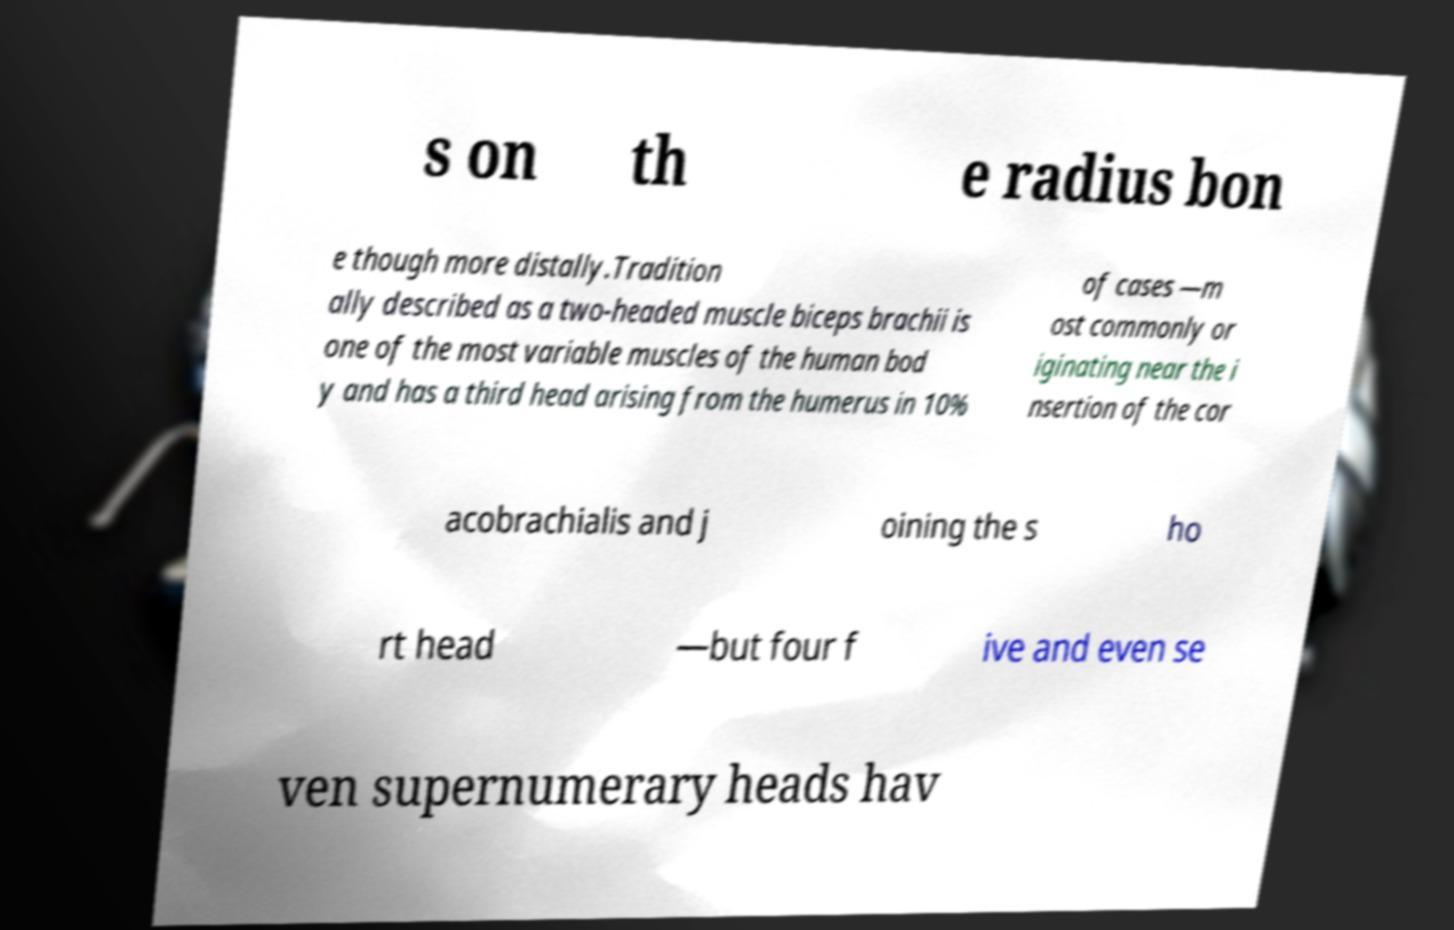Can you accurately transcribe the text from the provided image for me? s on th e radius bon e though more distally.Tradition ally described as a two-headed muscle biceps brachii is one of the most variable muscles of the human bod y and has a third head arising from the humerus in 10% of cases —m ost commonly or iginating near the i nsertion of the cor acobrachialis and j oining the s ho rt head —but four f ive and even se ven supernumerary heads hav 